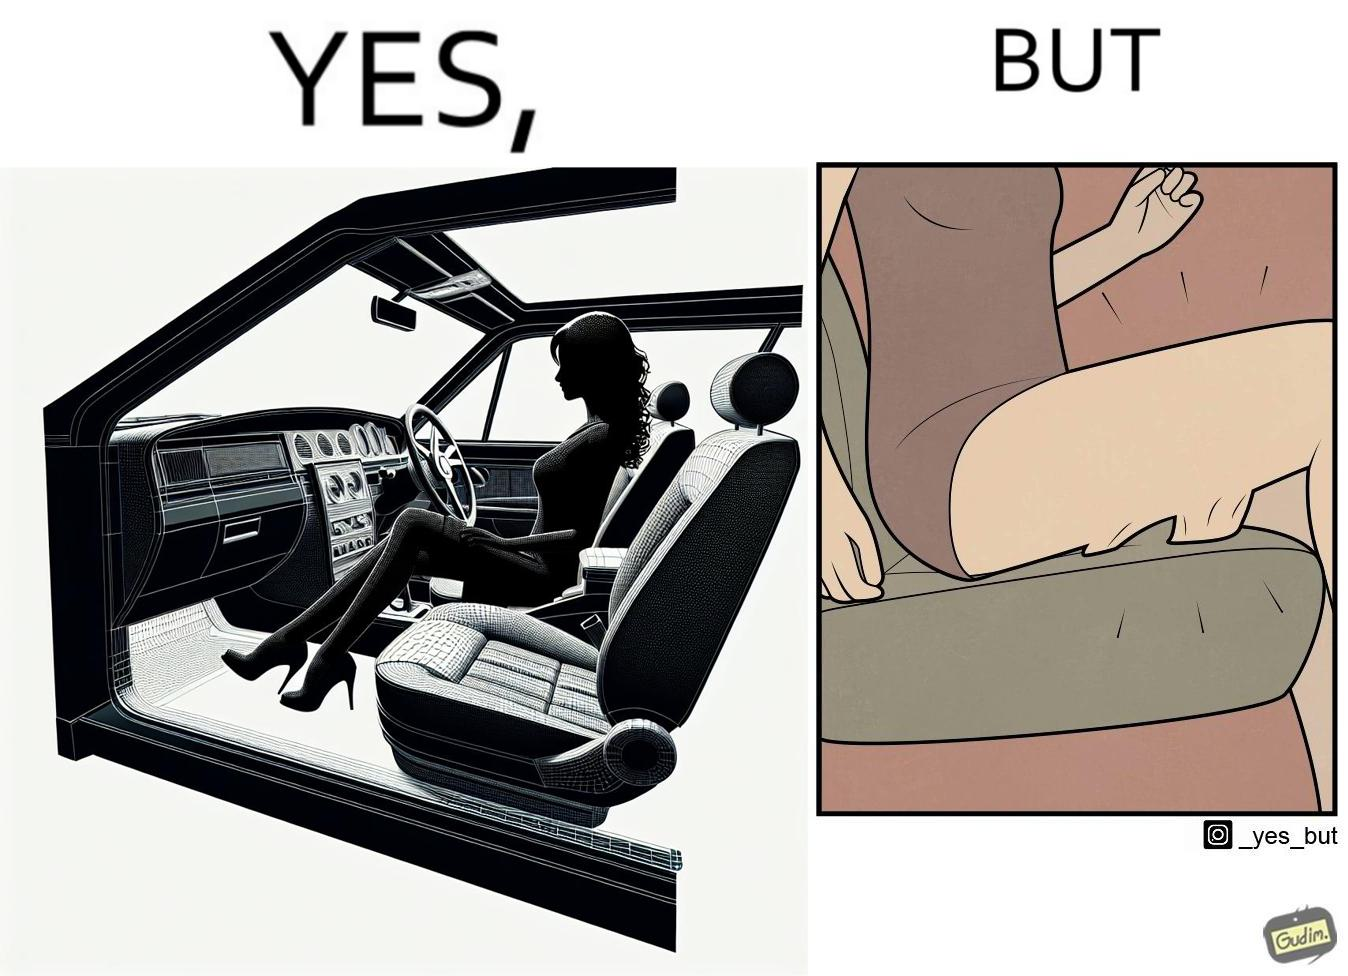Describe what you see in the left and right parts of this image. In the left part of the image: a woman wearing a short dress sitting on the co-passengers seat in a car In the right part of the image: skin of a woman getting sticked to the seat fabric of the car, causing inconvenience 